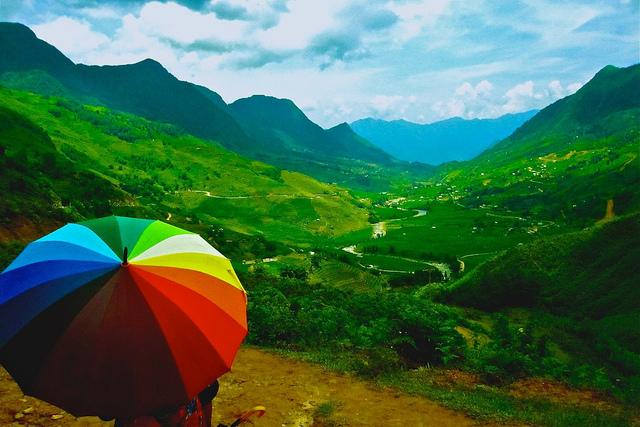What is colorful?
Answer briefly. Umbrella. What type of terrain surrounds the river?
Concise answer only. Mountains. Is it raining in this picture?
Short answer required. No. Is this a kite?
Be succinct. No. 